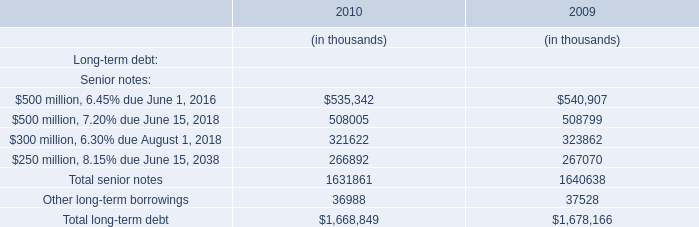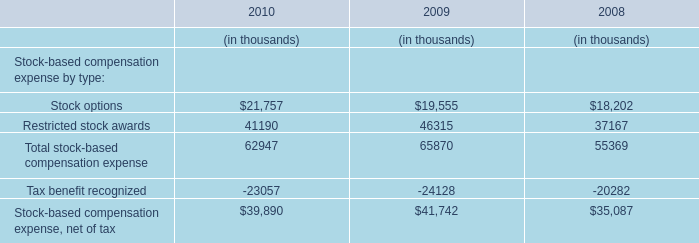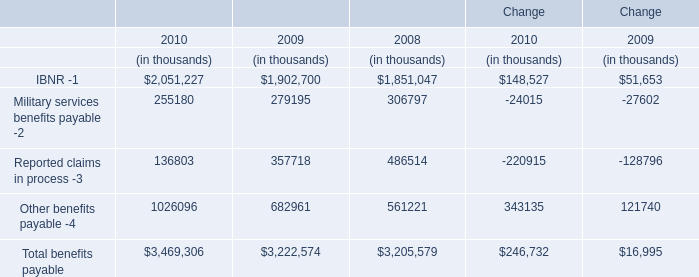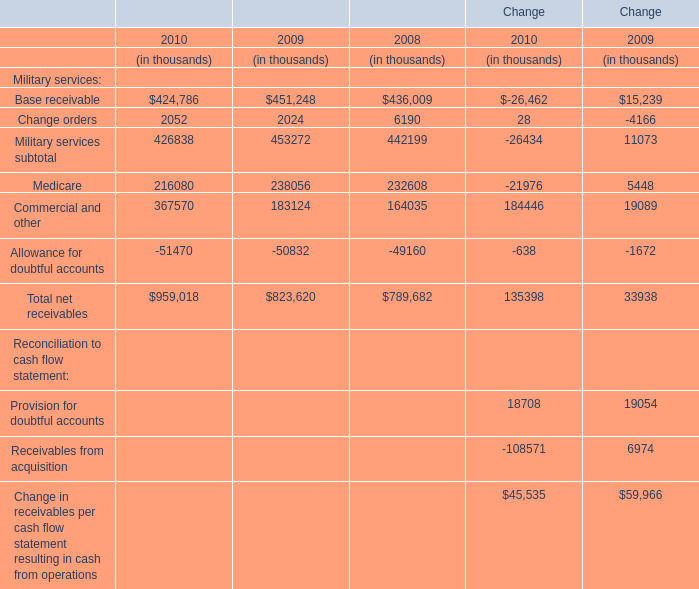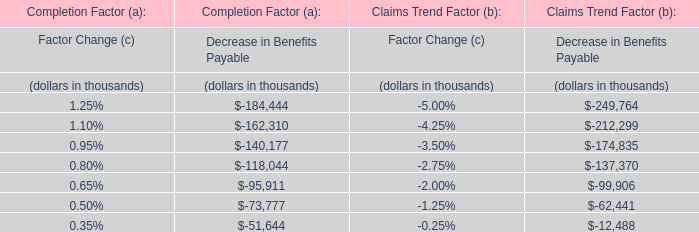What's the total value of all elements that are smaller than 200000 in 2008? (in thousand) 
Computations: ((6190 + 164035) - 49160)
Answer: 121065.0. 